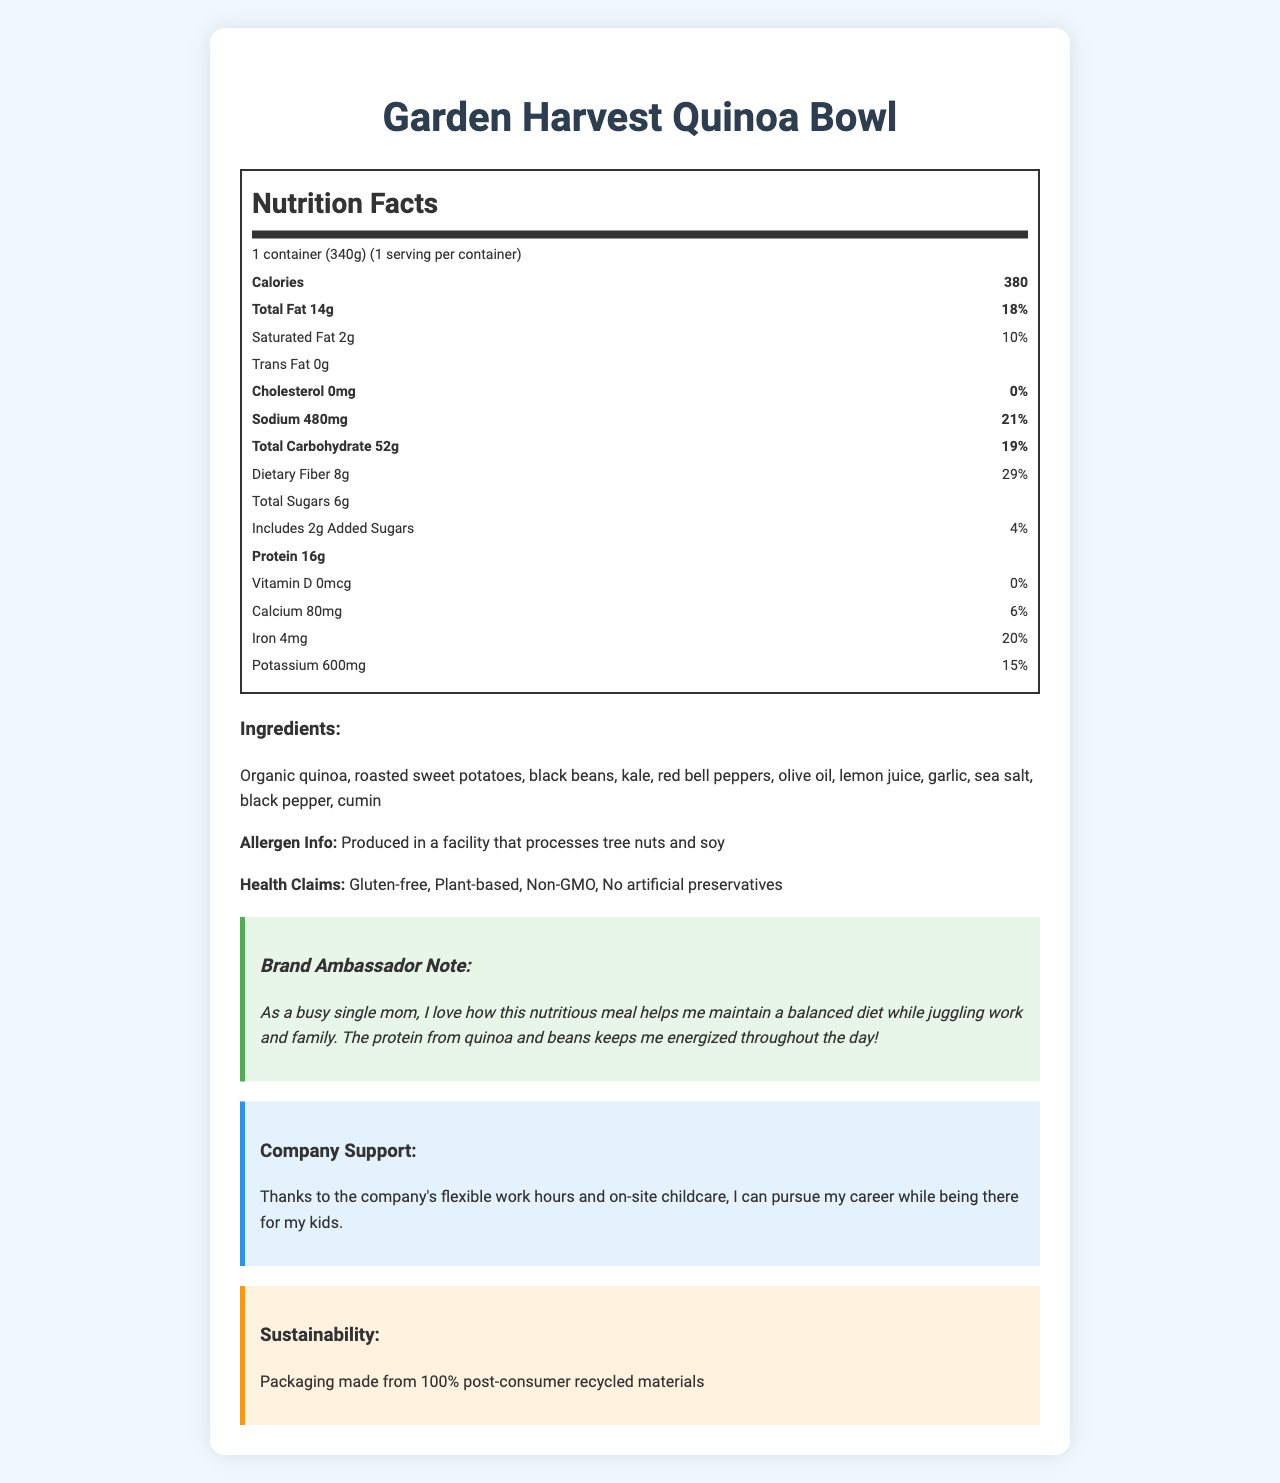what is the serving size? The serving size is clearly stated as "1 container (340g)."
Answer: 1 container (340g) how many calories are in one serving? It is mentioned that the total calories per serving are 380.
Answer: 380 calories how much total fat is in the Garden Harvest Quinoa Bowl? The Nutrition Facts label specifies "Total Fat 14g."
Answer: 14g how much protein is in one serving? The label indicates that one serving contains 16g of protein.
Answer: 16g what is the daily value percentage for dietary fiber? The Nutrition Facts show that dietary fiber is 8g, which is 29% of the daily value.
Answer: 29% what ingredient is not mentioned in the Nutrition Facts but might be an allergen? The Allergen Info mentions it is produced in a facility that processes tree nuts and soy.
Answer: Tree nuts and soy which of the following nutrients is present in the lowest daily value percentage? A. Sodium B. Calcium C. Iron D. Saturated Fat Although many nutrients are listed, Vitamin D has the lowest daily value percentage with 0%.
Answer: Vitamin D are there any artificial preservatives in this product? The health claims section specifically states "No artificial preservatives."
Answer: No is the product gluten-free and plant-based? The health claims label the product as "Gluten-free" and "Plant-based."
Answer: Yes describe the main idea of the document The main idea centers on providing comprehensive nutritional details, ingredients, health claims, and additional insights from the brand ambassador about the product's benefits and company support.
Answer: The document provides detailed nutritional information about the Garden Harvest Quinoa Bowl, a gluten-free, plant-based frozen dinner. It highlights the balanced macronutrients, including a good protein source, moderate fat, and carbohydrates. The ingredients underscore its natural, non-GMO status with no artificial preservatives. The document also includes endorsements from a brand ambassador focusing on nutritional benefits and the company's supportive policies for employees and its sustainability efforts. how many grams of added sugars are in the Garden Harvest Quinoa Bowl? The Nutrition Facts label indicates there are 2g of added sugars.
Answer: 2g what is the amount of sodium in this product? A. 280mg B. 480mg C. 680mg D. 580mg The Nutrition Facts list the sodium amount as 480mg.
Answer: B. 480mg does the Garden Harvest Quinoa Bowl contain any cholesterol? The document states "Cholesterol 0mg (0%)."
Answer: No how much iron does a serving of the Bowl provide based on daily value percentage? The Nutrition Facts specify that each serving provides 4mg of iron, which is 20% of the daily value.
Answer: 20% what type of packaging is used for this product? The sustainability section notes that the packaging is made from 100% post-consumer recycled materials.
Answer: The packaging is made from 100% post-consumer recycled materials. how does the company's support benefit the brand ambassador as a single mom? The ambassador note details how the company's supportive policies assist her.
Answer: The company's flexible work hours and on-site childcare help her pursue her career while being there for her kids. what specific vitamins and minerals are listed in the document? The Nutrition Facts section lists Vitamin D, Calcium, Iron, and Potassium.
Answer: Vitamin D, Calcium, Iron, Potassium what are the health claims made for the Garden Harvest Quinoa Bowl? The health claims section enumerates these specific claims.
Answer: Gluten-free, Plant-based, Non-GMO, No artificial preservatives which vitamin has a daily value of 0%? The Nutrition Facts label shows that Vitamin D has a 0% daily value.
Answer: Vitamin D what are the primary ingredients of the Garden Harvest Quinoa Bowl? The ingredients list includes these items.
Answer: Organic quinoa, roasted sweet potatoes, black beans, kale, red bell peppers, olive oil, lemon juice, garlic, sea salt, black pepper, cumin is the ingredient list comprehensive enough to verify no gluten ingredients are included? Although it lists the ingredients, it cannot be determined only from the ingredient list if there is a cross-contamination risk or if it might contain trace gluten. The gluten-free claim does help, but a detailed allergen process is not provided.
Answer: Not enough information 